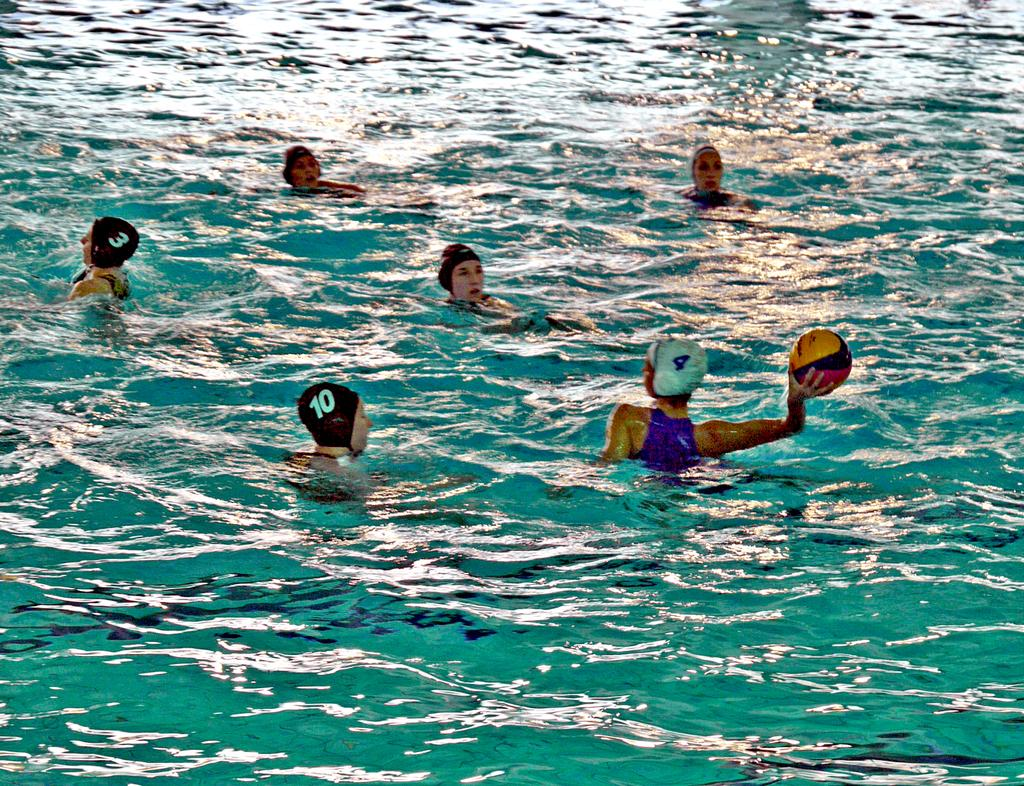What are the people in the image doing? The people in the image are in the water. What are the people wearing on their heads? The people are wearing caps. Can you describe the object held by the person on the right side? The person on the right side is holding a ball in his hand. What type of chin can be seen on the person holding the ball? There is no chin visible in the image, as the people are in the water and their faces are not shown. 